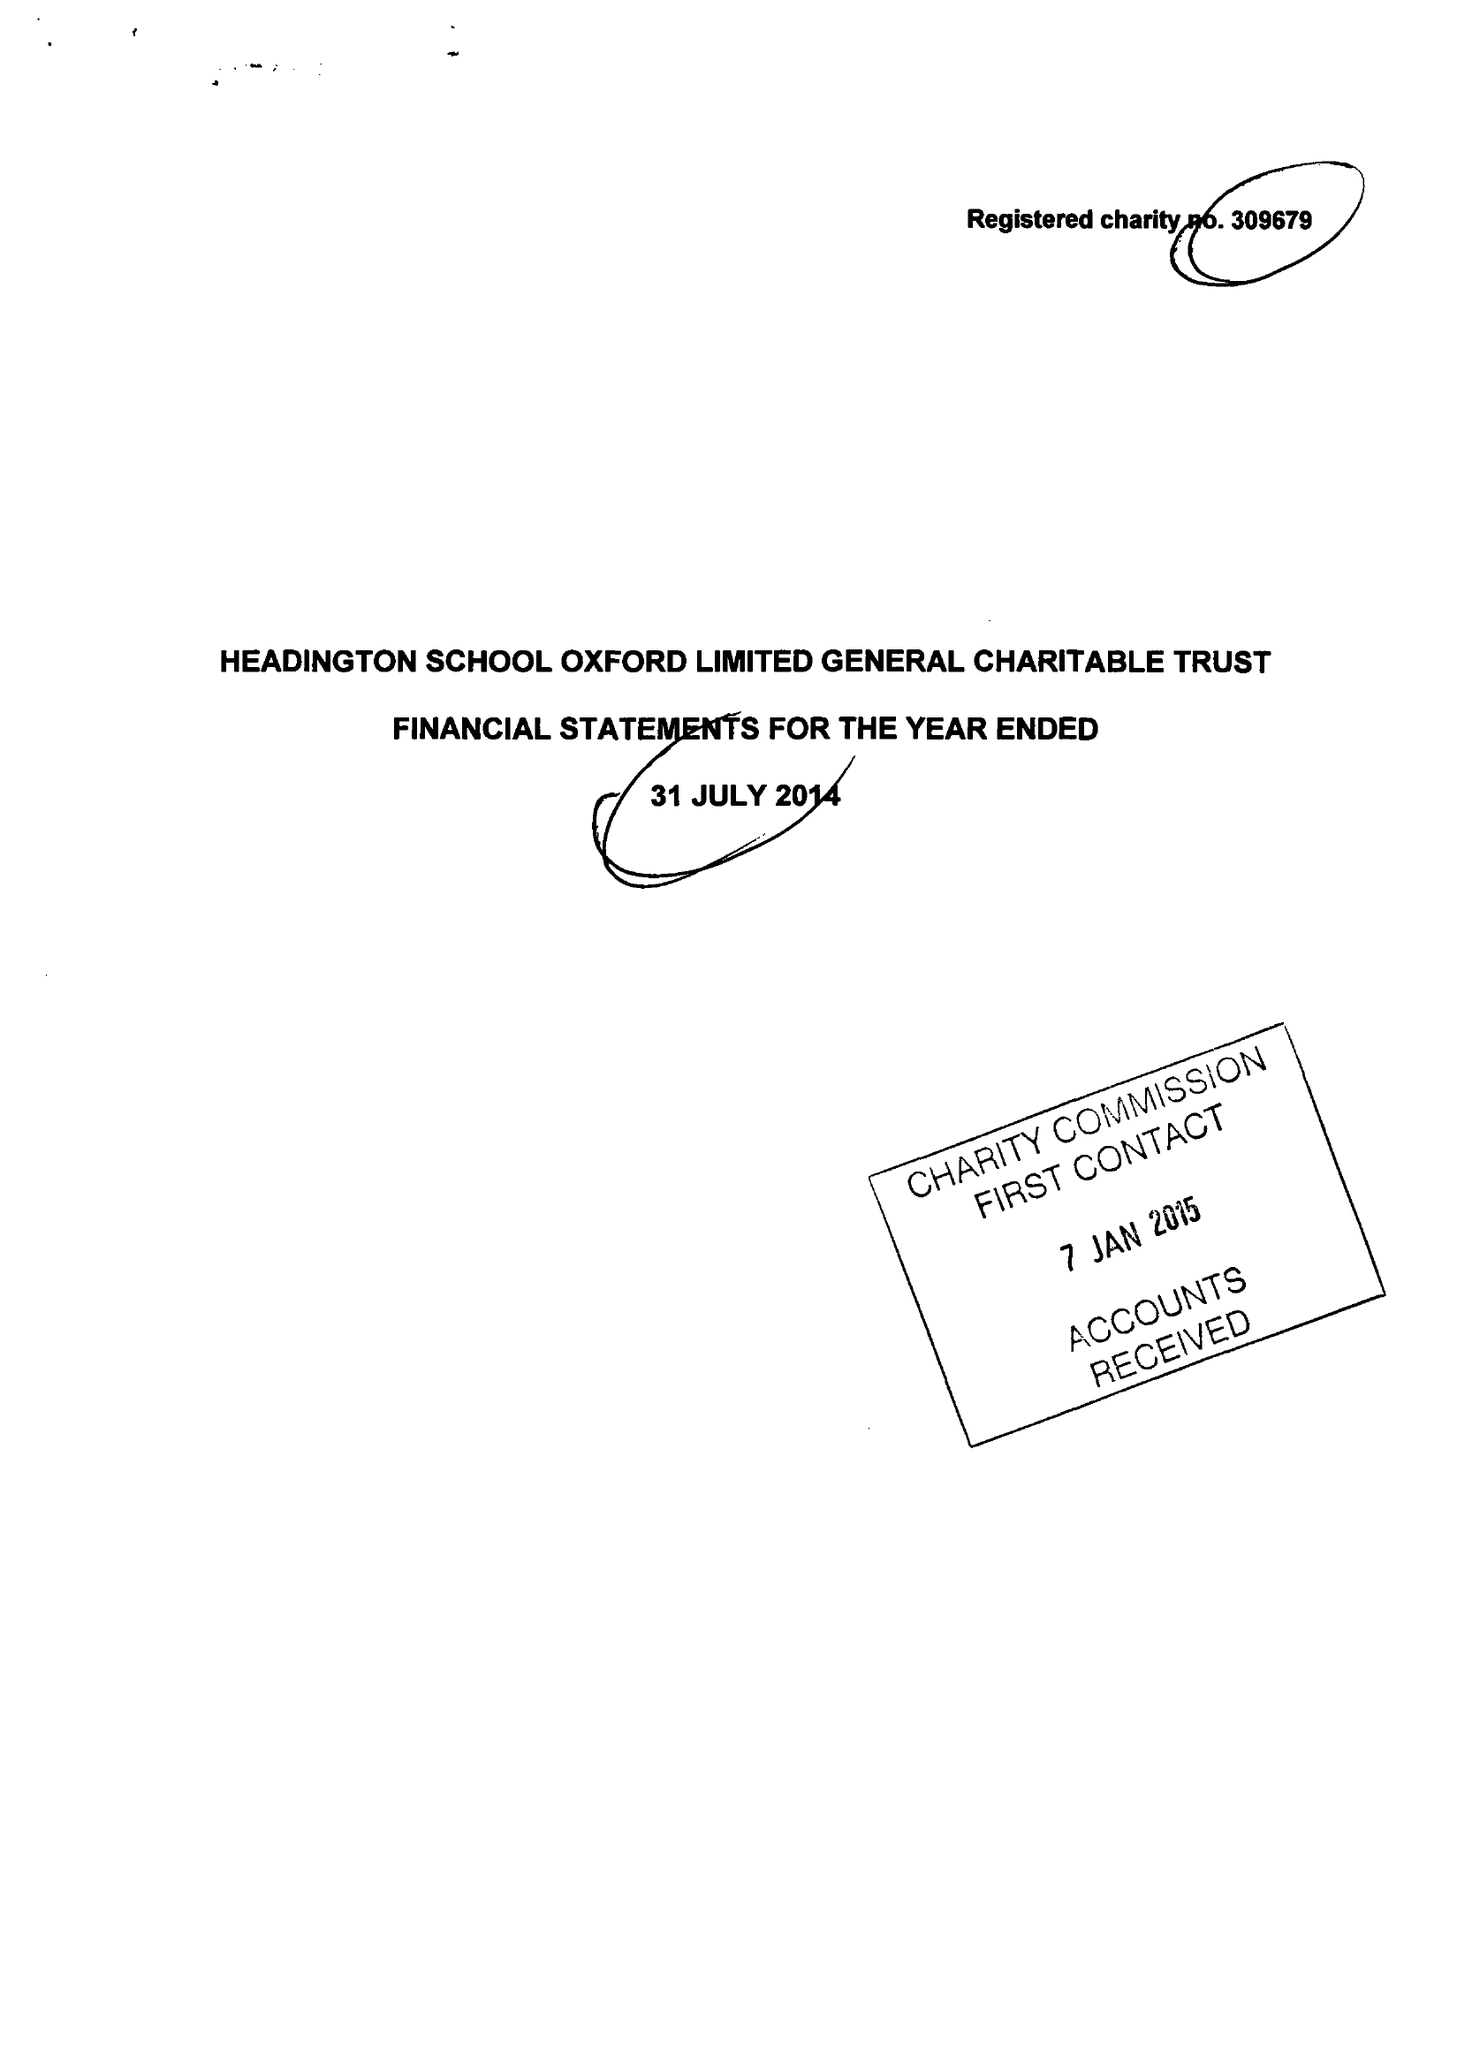What is the value for the spending_annually_in_british_pounds?
Answer the question using a single word or phrase. 83159.00 